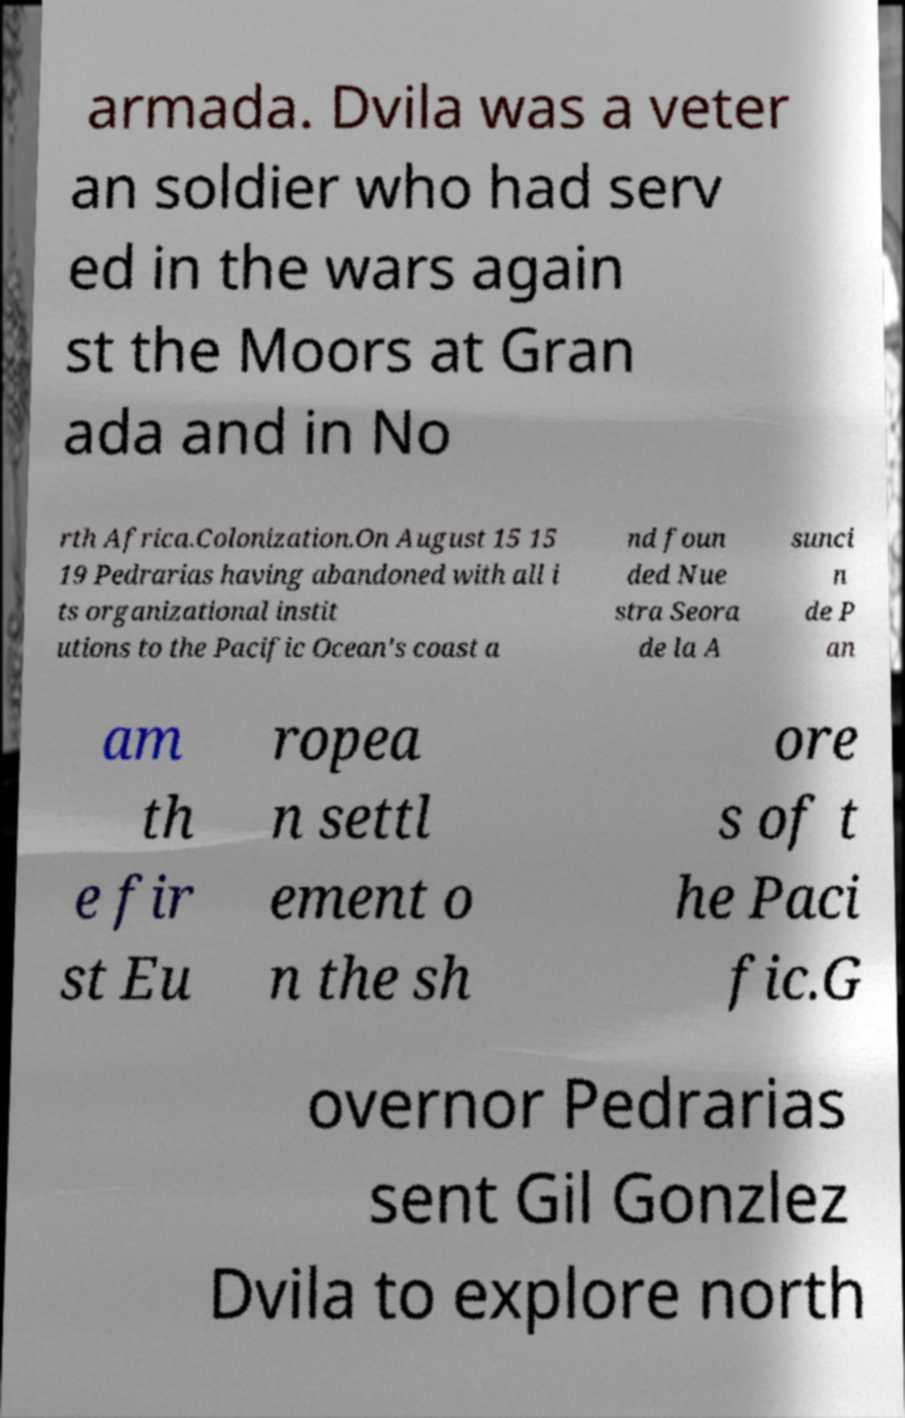I need the written content from this picture converted into text. Can you do that? armada. Dvila was a veter an soldier who had serv ed in the wars again st the Moors at Gran ada and in No rth Africa.Colonization.On August 15 15 19 Pedrarias having abandoned with all i ts organizational instit utions to the Pacific Ocean's coast a nd foun ded Nue stra Seora de la A sunci n de P an am th e fir st Eu ropea n settl ement o n the sh ore s of t he Paci fic.G overnor Pedrarias sent Gil Gonzlez Dvila to explore north 